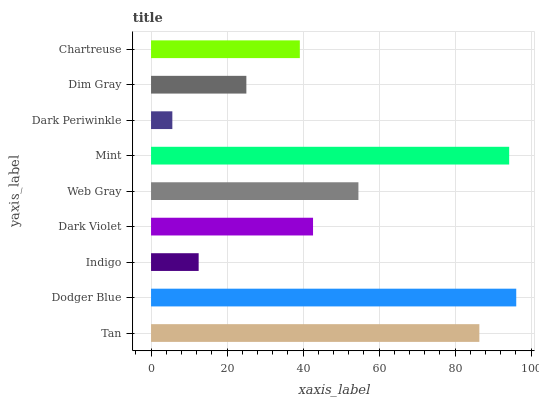Is Dark Periwinkle the minimum?
Answer yes or no. Yes. Is Dodger Blue the maximum?
Answer yes or no. Yes. Is Indigo the minimum?
Answer yes or no. No. Is Indigo the maximum?
Answer yes or no. No. Is Dodger Blue greater than Indigo?
Answer yes or no. Yes. Is Indigo less than Dodger Blue?
Answer yes or no. Yes. Is Indigo greater than Dodger Blue?
Answer yes or no. No. Is Dodger Blue less than Indigo?
Answer yes or no. No. Is Dark Violet the high median?
Answer yes or no. Yes. Is Dark Violet the low median?
Answer yes or no. Yes. Is Web Gray the high median?
Answer yes or no. No. Is Indigo the low median?
Answer yes or no. No. 